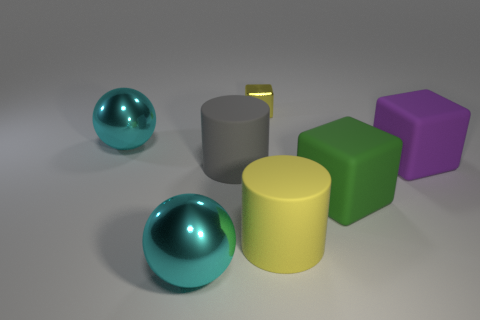What material is the cube that is the same size as the purple matte object?
Offer a very short reply. Rubber. There is a tiny yellow thing; what number of small yellow things are on the right side of it?
Your answer should be very brief. 0. There is a matte object on the left side of the tiny yellow block; is it the same shape as the small yellow metallic thing?
Make the answer very short. No. Are there any yellow rubber objects of the same shape as the large purple matte object?
Your response must be concise. No. There is a large object that is the same color as the tiny shiny block; what is its material?
Offer a terse response. Rubber. What shape is the object that is left of the large metallic object that is in front of the big green cube?
Your response must be concise. Sphere. What number of other small cubes are made of the same material as the green cube?
Your answer should be compact. 0. What is the color of the cylinder that is the same material as the gray thing?
Your answer should be compact. Yellow. There is a cylinder left of the yellow thing that is in front of the big rubber cylinder left of the small yellow thing; how big is it?
Give a very brief answer. Large. Is the number of cyan metallic balls less than the number of yellow matte things?
Your answer should be compact. No. 